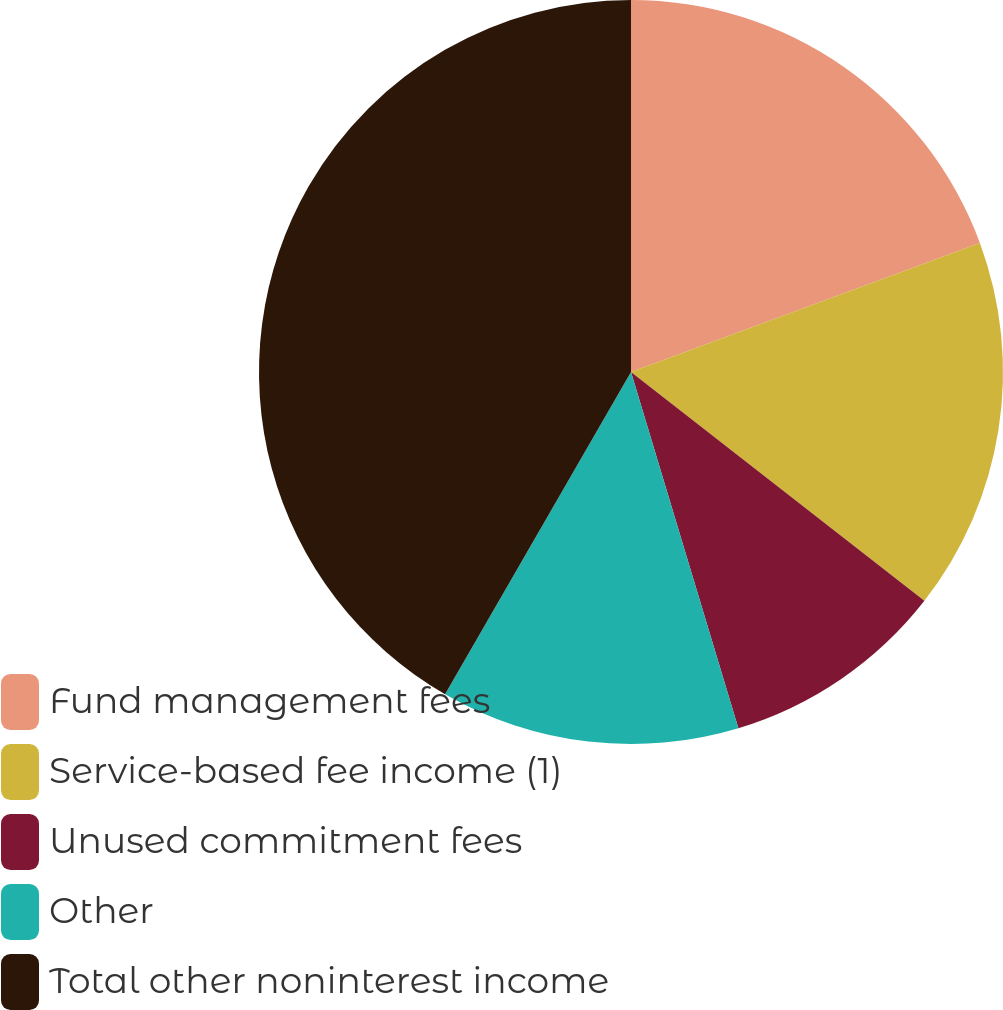Convert chart to OTSL. <chart><loc_0><loc_0><loc_500><loc_500><pie_chart><fcel>Fund management fees<fcel>Service-based fee income (1)<fcel>Unused commitment fees<fcel>Other<fcel>Total other noninterest income<nl><fcel>19.36%<fcel>16.18%<fcel>9.8%<fcel>12.99%<fcel>41.67%<nl></chart> 